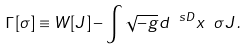<formula> <loc_0><loc_0><loc_500><loc_500>\Gamma [ \sigma ] \equiv W [ J ] - \int \sqrt { - g } d ^ { \ s D } x \ \sigma J \, .</formula> 